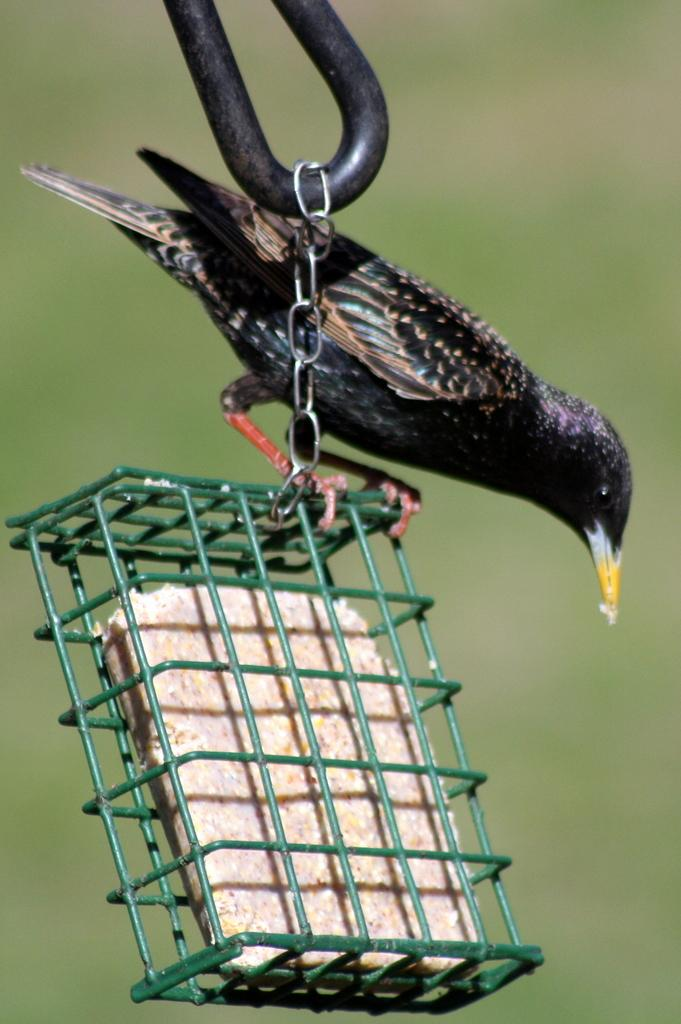What type of animal can be seen in the image? There is a bird in the image. What is the bird contained within? There is a small cage in the image. What is inside the cage with the bird? There is food in the cage. What type of restraint is present in the image? There is a chain in the image. What type of legal advice is the bird seeking from the lawyer in the image? There is no lawyer present in the image, and the bird is not seeking legal advice. 